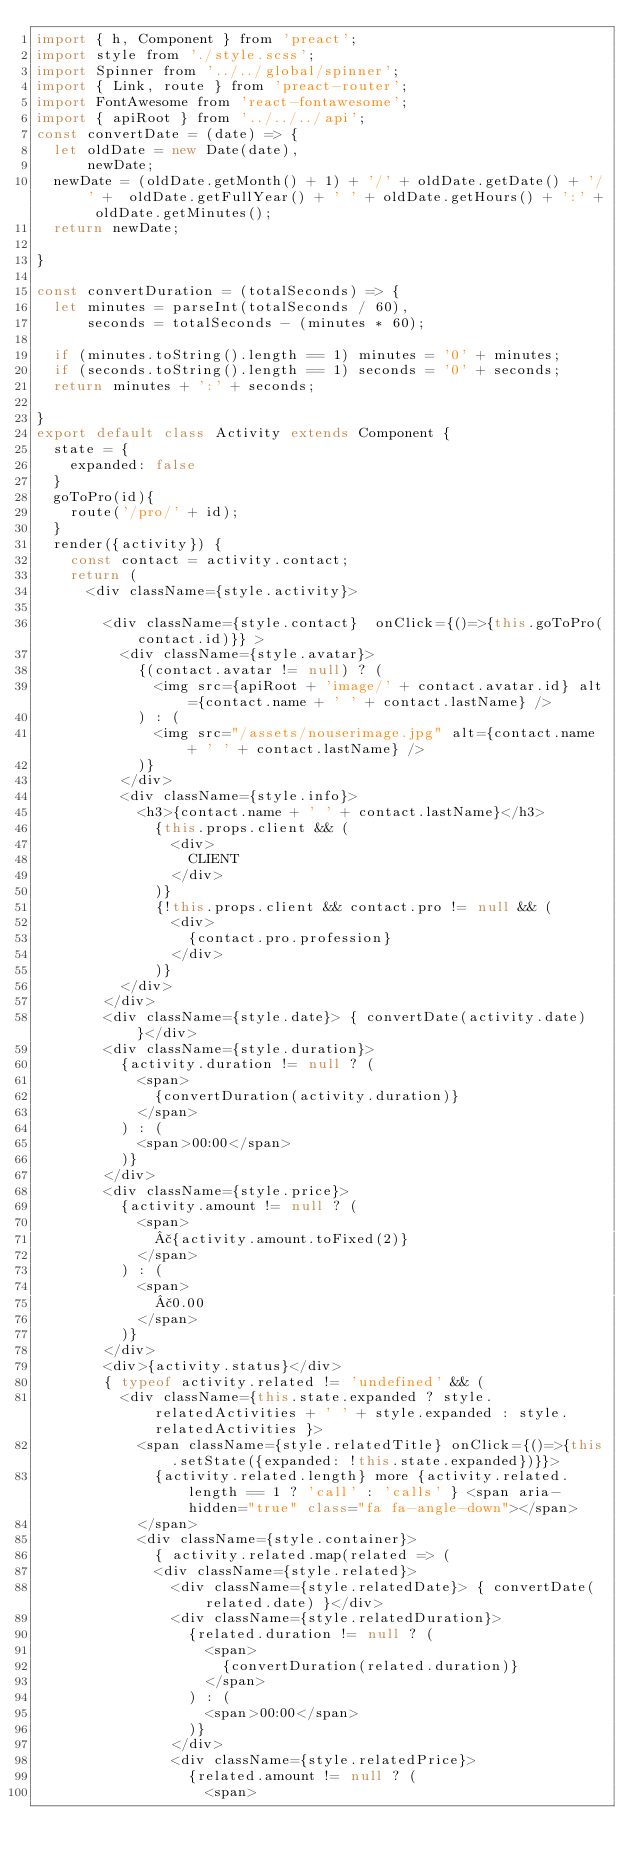Convert code to text. <code><loc_0><loc_0><loc_500><loc_500><_JavaScript_>import { h, Component } from 'preact';
import style from './style.scss';
import Spinner from '../../global/spinner';
import { Link, route } from 'preact-router';
import FontAwesome from 'react-fontawesome';
import { apiRoot } from '../../../api';
const convertDate = (date) => {
	let oldDate = new Date(date),
			newDate;
	newDate = (oldDate.getMonth() + 1) + '/' + oldDate.getDate() + '/' +  oldDate.getFullYear() + ' ' + oldDate.getHours() + ':' + oldDate.getMinutes();
	return newDate;

}

const convertDuration = (totalSeconds) => {
	let minutes = parseInt(totalSeconds / 60),
			seconds = totalSeconds - (minutes * 60);

	if (minutes.toString().length == 1) minutes = '0' + minutes;
	if (seconds.toString().length == 1) seconds = '0' + seconds;
	return minutes + ':' + seconds;

}
export default class Activity extends Component {
	state = {
		expanded: false
	}
	goToPro(id){
		route('/pro/' + id);
	}
	render({activity}) {
		const contact = activity.contact;
		return (
			<div className={style.activity}>

				<div className={style.contact}  onClick={()=>{this.goToPro(contact.id)}} >
					<div className={style.avatar}>
						{(contact.avatar != null) ? (
							<img src={apiRoot + 'image/' + contact.avatar.id} alt={contact.name + ' ' + contact.lastName} />
						) : (
							<img src="/assets/nouserimage.jpg" alt={contact.name + ' ' + contact.lastName} />
						)}
					</div>
					<div className={style.info}>
						<h3>{contact.name + ' ' + contact.lastName}</h3>
							{this.props.client && (
								<div>
									CLIENT
								</div>
							)}
							{!this.props.client && contact.pro != null && (
								<div>
									{contact.pro.profession}
								</div>
							)}
					</div>
				</div>
				<div className={style.date}> { convertDate(activity.date) }</div>
				<div className={style.duration}>
					{activity.duration != null ? (
						<span>
							{convertDuration(activity.duration)}
						</span>
					) : (
						<span>00:00</span>
					)}
				</div>
				<div className={style.price}>
					{activity.amount != null ? (
						<span>
							£{activity.amount.toFixed(2)}
						</span>
					) : (
						<span>
							£0.00
						</span>
					)}
				</div>
				<div>{activity.status}</div>
				{ typeof activity.related != 'undefined' && (
					<div className={this.state.expanded ? style.relatedActivities + ' ' + style.expanded : style.relatedActivities }>
						<span className={style.relatedTitle} onClick={()=>{this.setState({expanded: !this.state.expanded})}}>
							{activity.related.length} more {activity.related.length == 1 ? 'call' : 'calls' } <span aria-hidden="true" class="fa fa-angle-down"></span>
						</span>
						<div className={style.container}>
							{ activity.related.map(related => (
							<div className={style.related}>
								<div className={style.relatedDate}> { convertDate(related.date) }</div>
								<div className={style.relatedDuration}>
									{related.duration != null ? (
										<span>
											{convertDuration(related.duration)}
										</span>
									) : (
										<span>00:00</span>
									)}
								</div>
								<div className={style.relatedPrice}>
									{related.amount != null ? (
										<span></code> 